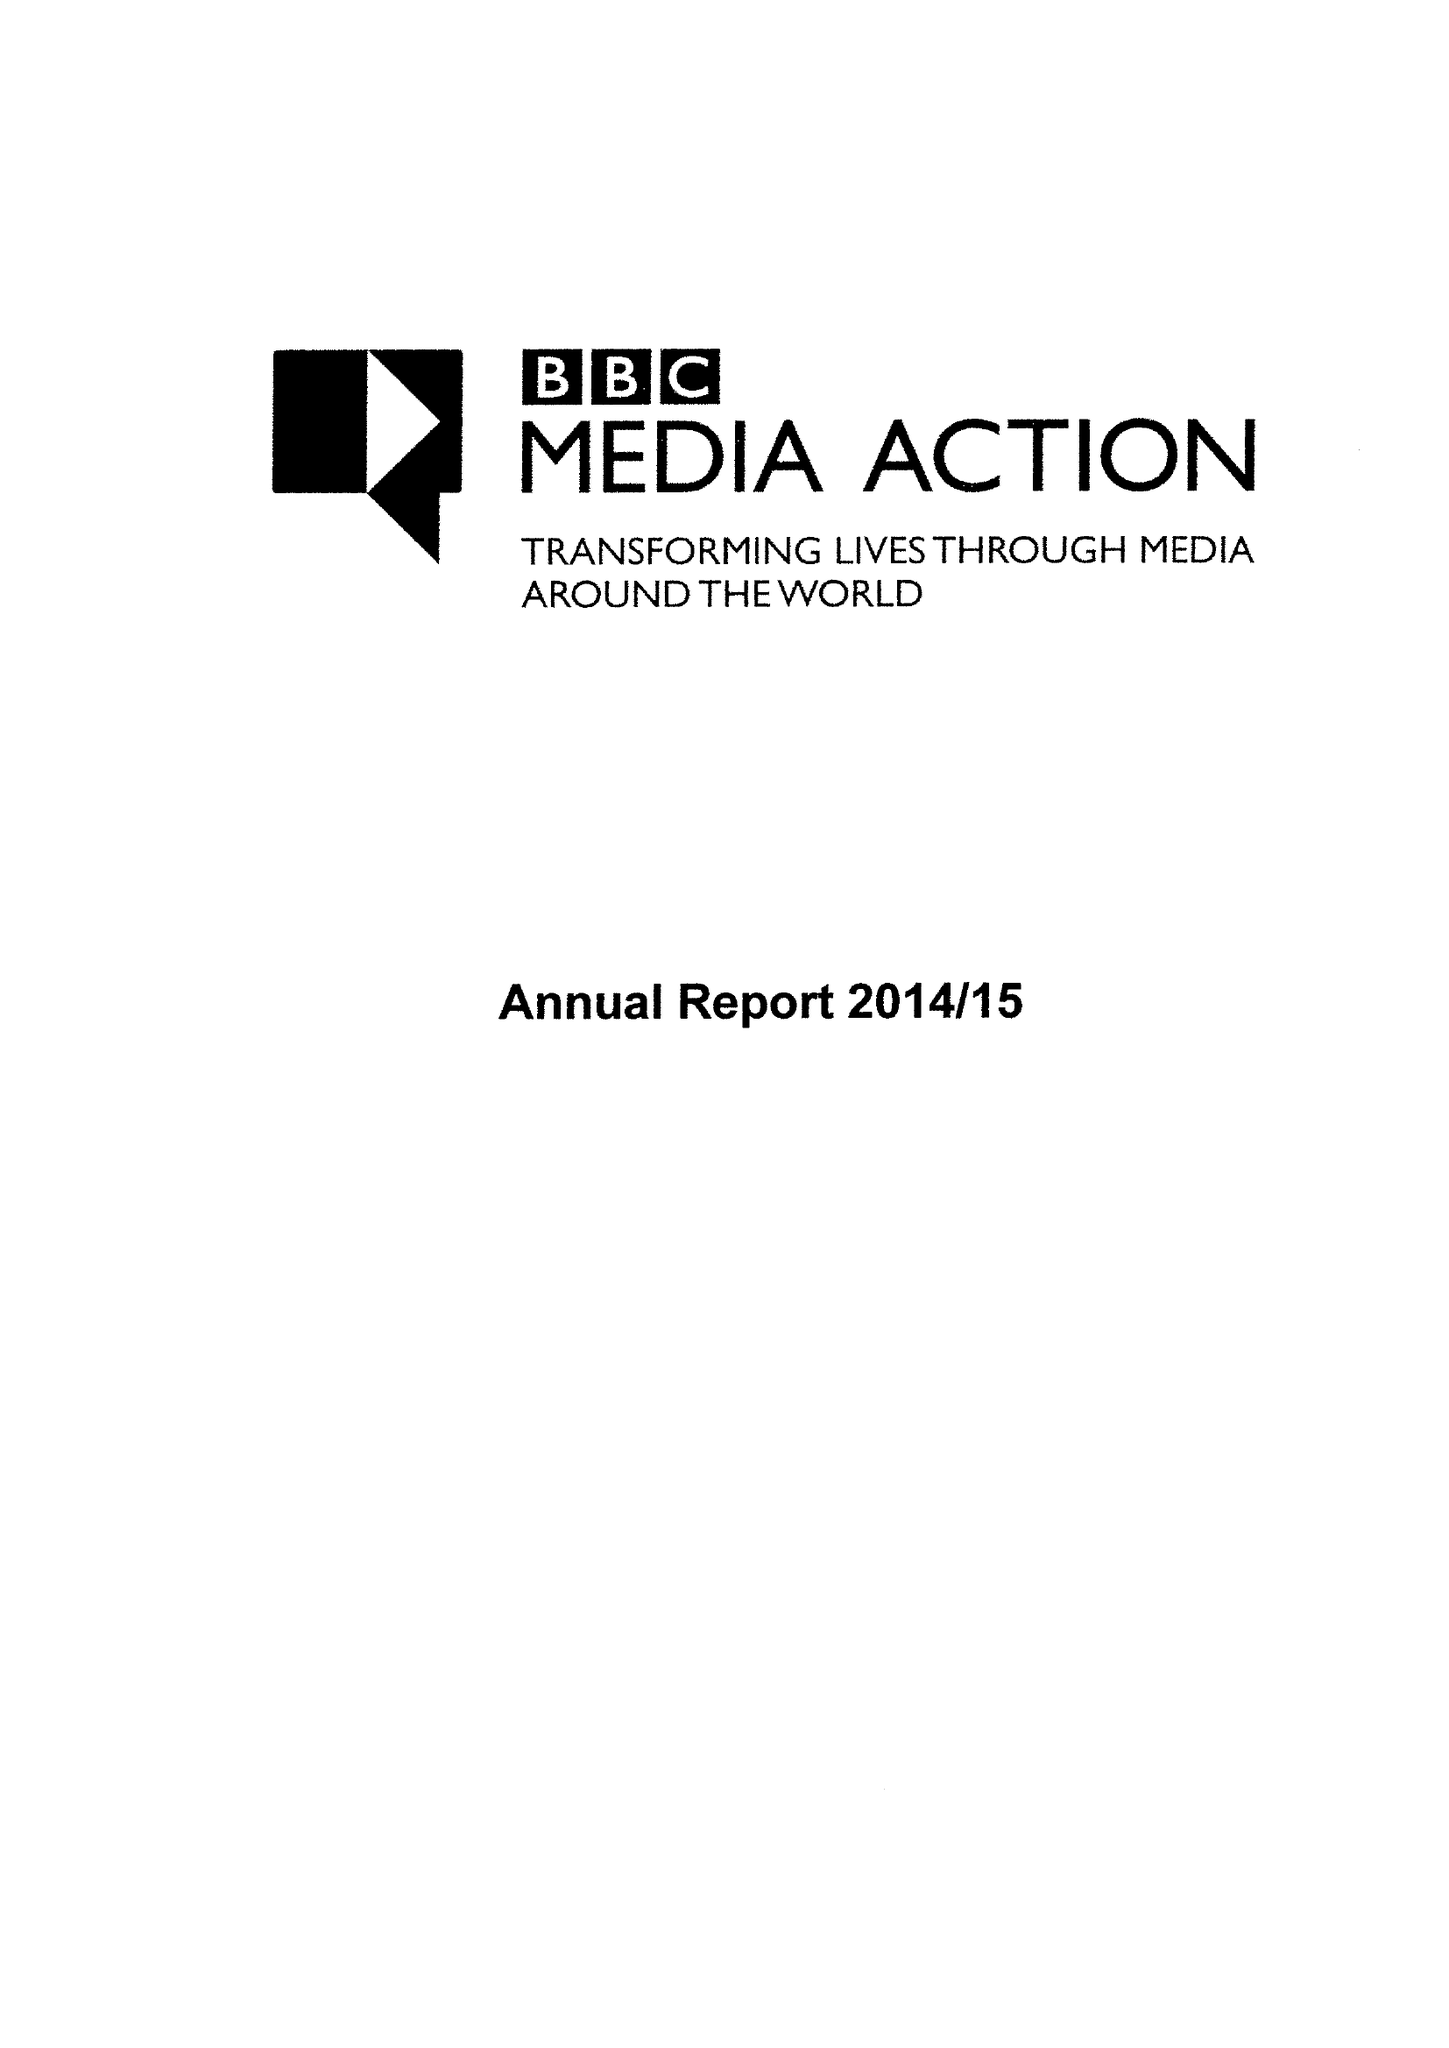What is the value for the address__street_line?
Answer the question using a single word or phrase. PORTLAND PLACE 